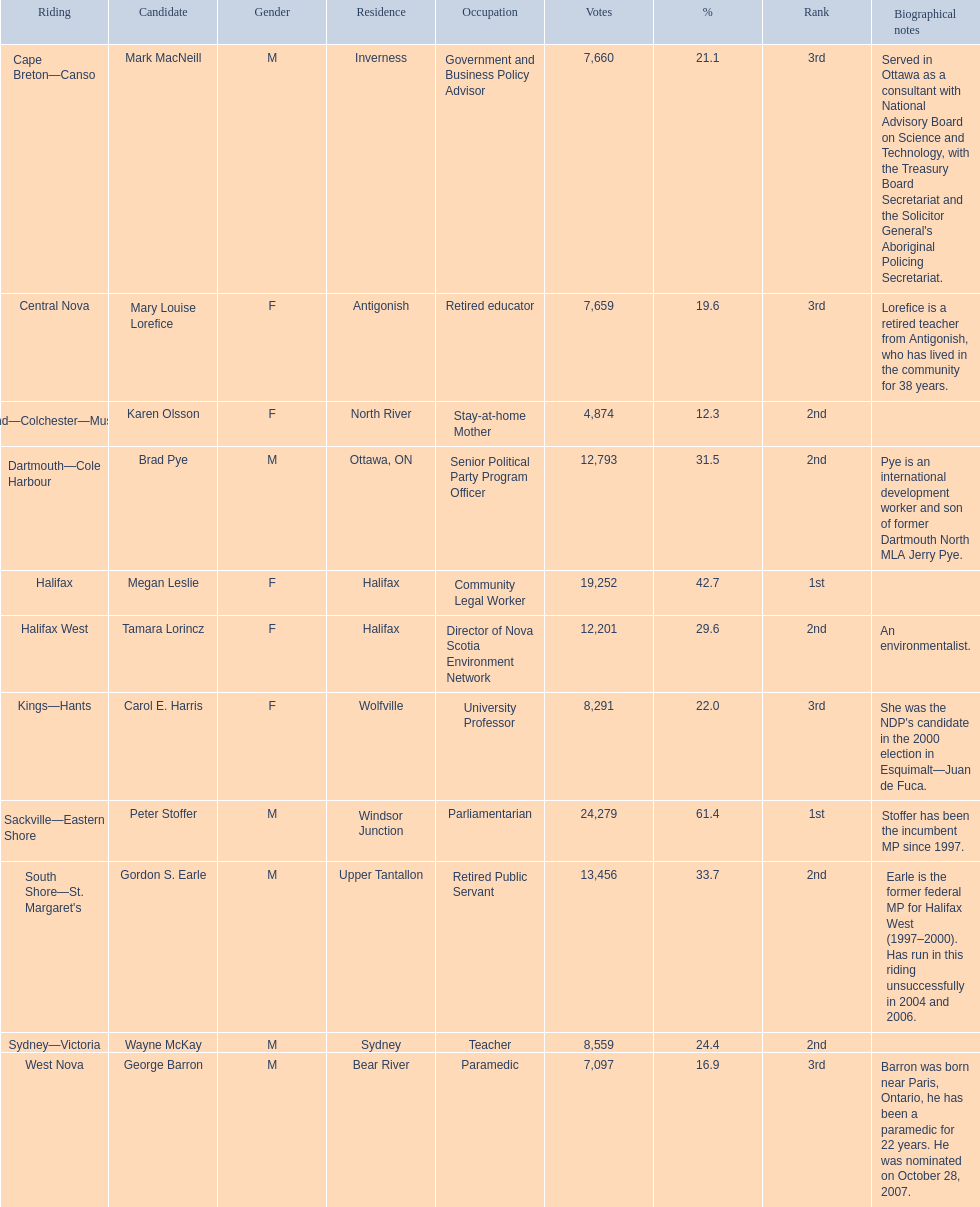What is the vote count for macneill? 7,660. What is the vote count for olsoon? 4,874. Who got more votes, macneil or olsson? Mark MacNeill. 